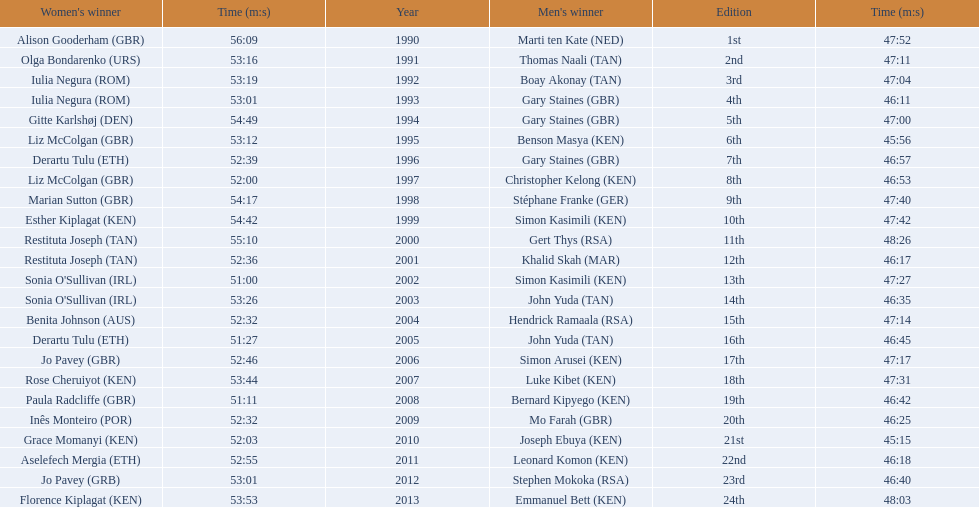What place did sonia o'sullivan finish in 2003? 14th. How long did it take her to finish? 53:26. 